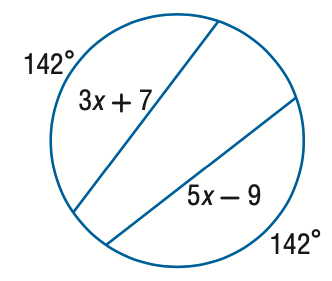Answer the mathemtical geometry problem and directly provide the correct option letter.
Question: Find the value of x.
Choices: A: 6 B: 7 C: 8 D: 9 C 